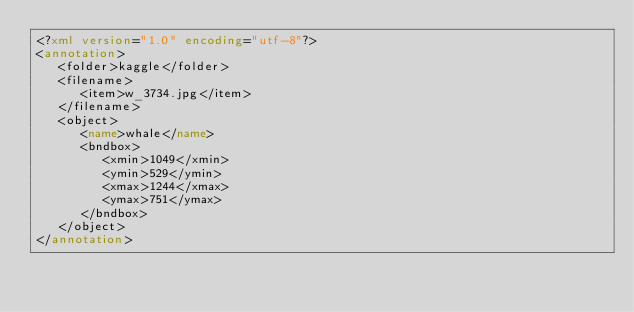<code> <loc_0><loc_0><loc_500><loc_500><_XML_><?xml version="1.0" encoding="utf-8"?>
<annotation>
   <folder>kaggle</folder>
   <filename>
      <item>w_3734.jpg</item>
   </filename>
   <object>
      <name>whale</name>
      <bndbox>
         <xmin>1049</xmin>
         <ymin>529</ymin>
         <xmax>1244</xmax>
         <ymax>751</ymax>
      </bndbox>
   </object>
</annotation></code> 